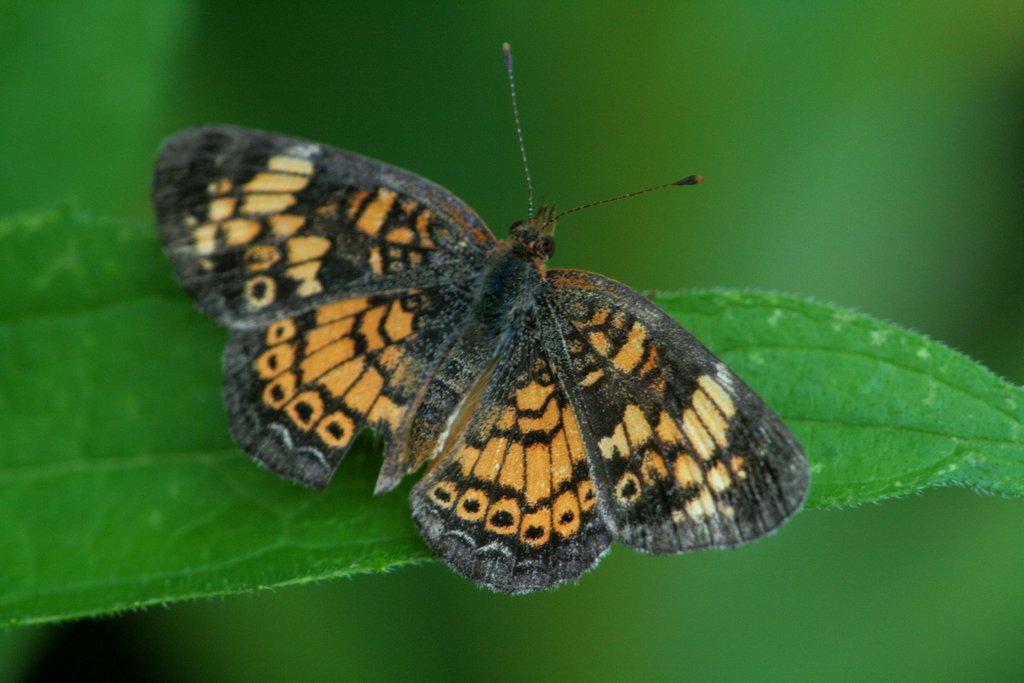What type of insect is present in the image? There is a butterfly in the image. What colors can be seen on the butterfly? The butterfly is orange and black in color. What other object is visible in the image? There is a leaf in the image. How would you describe the background of the image? The background of the image is blurred. What time is displayed on the clock in the image? There is no clock present in the image. Is the butterfly in jail in the image? There is no jail or any indication of confinement in the image; the butterfly is freely flying near a leaf. 